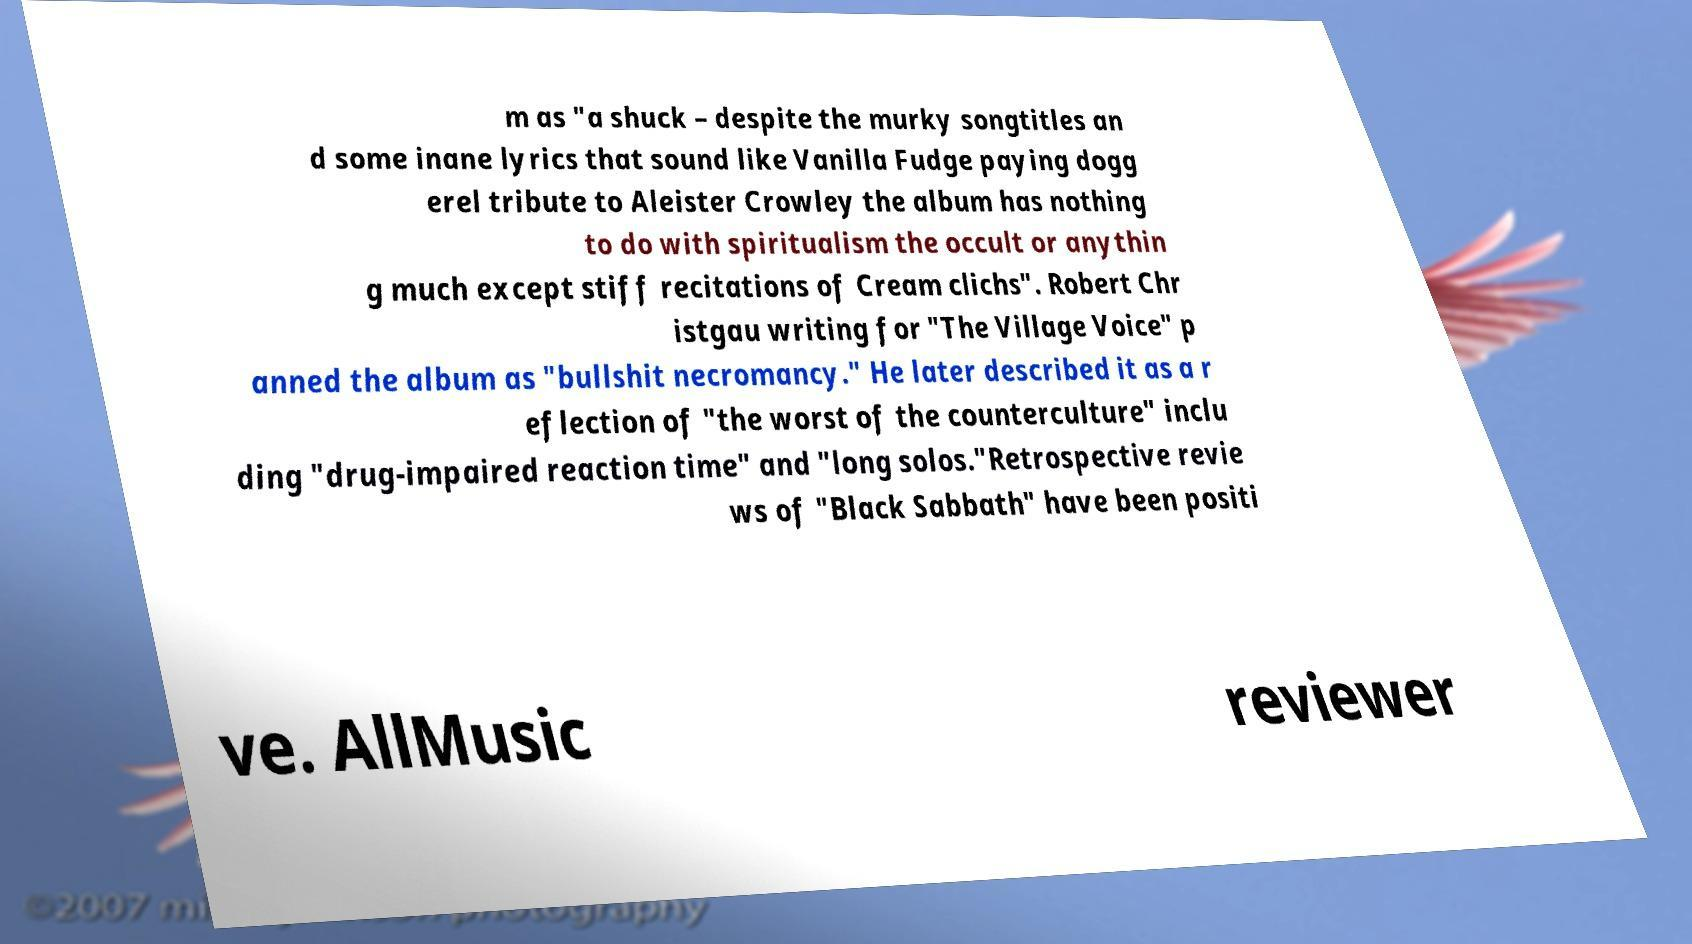Can you read and provide the text displayed in the image?This photo seems to have some interesting text. Can you extract and type it out for me? m as "a shuck – despite the murky songtitles an d some inane lyrics that sound like Vanilla Fudge paying dogg erel tribute to Aleister Crowley the album has nothing to do with spiritualism the occult or anythin g much except stiff recitations of Cream clichs". Robert Chr istgau writing for "The Village Voice" p anned the album as "bullshit necromancy." He later described it as a r eflection of "the worst of the counterculture" inclu ding "drug-impaired reaction time" and "long solos."Retrospective revie ws of "Black Sabbath" have been positi ve. AllMusic reviewer 